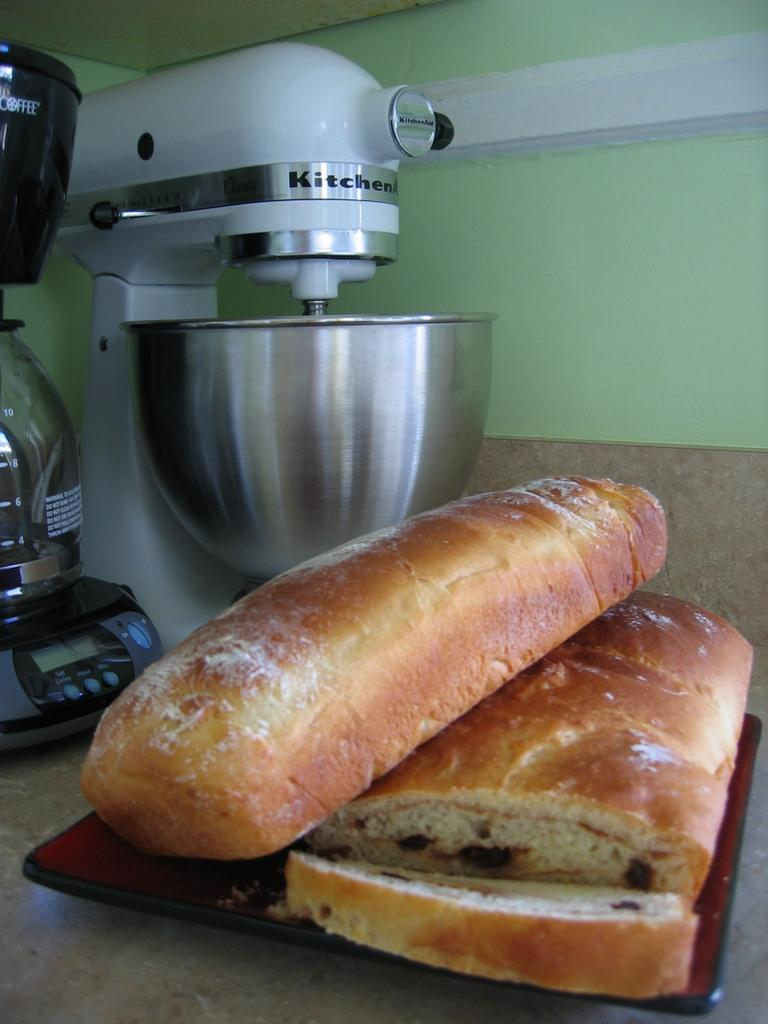Provide a one-sentence caption for the provided image. A KitchenAid mixer sits next to some loaves of bread. 